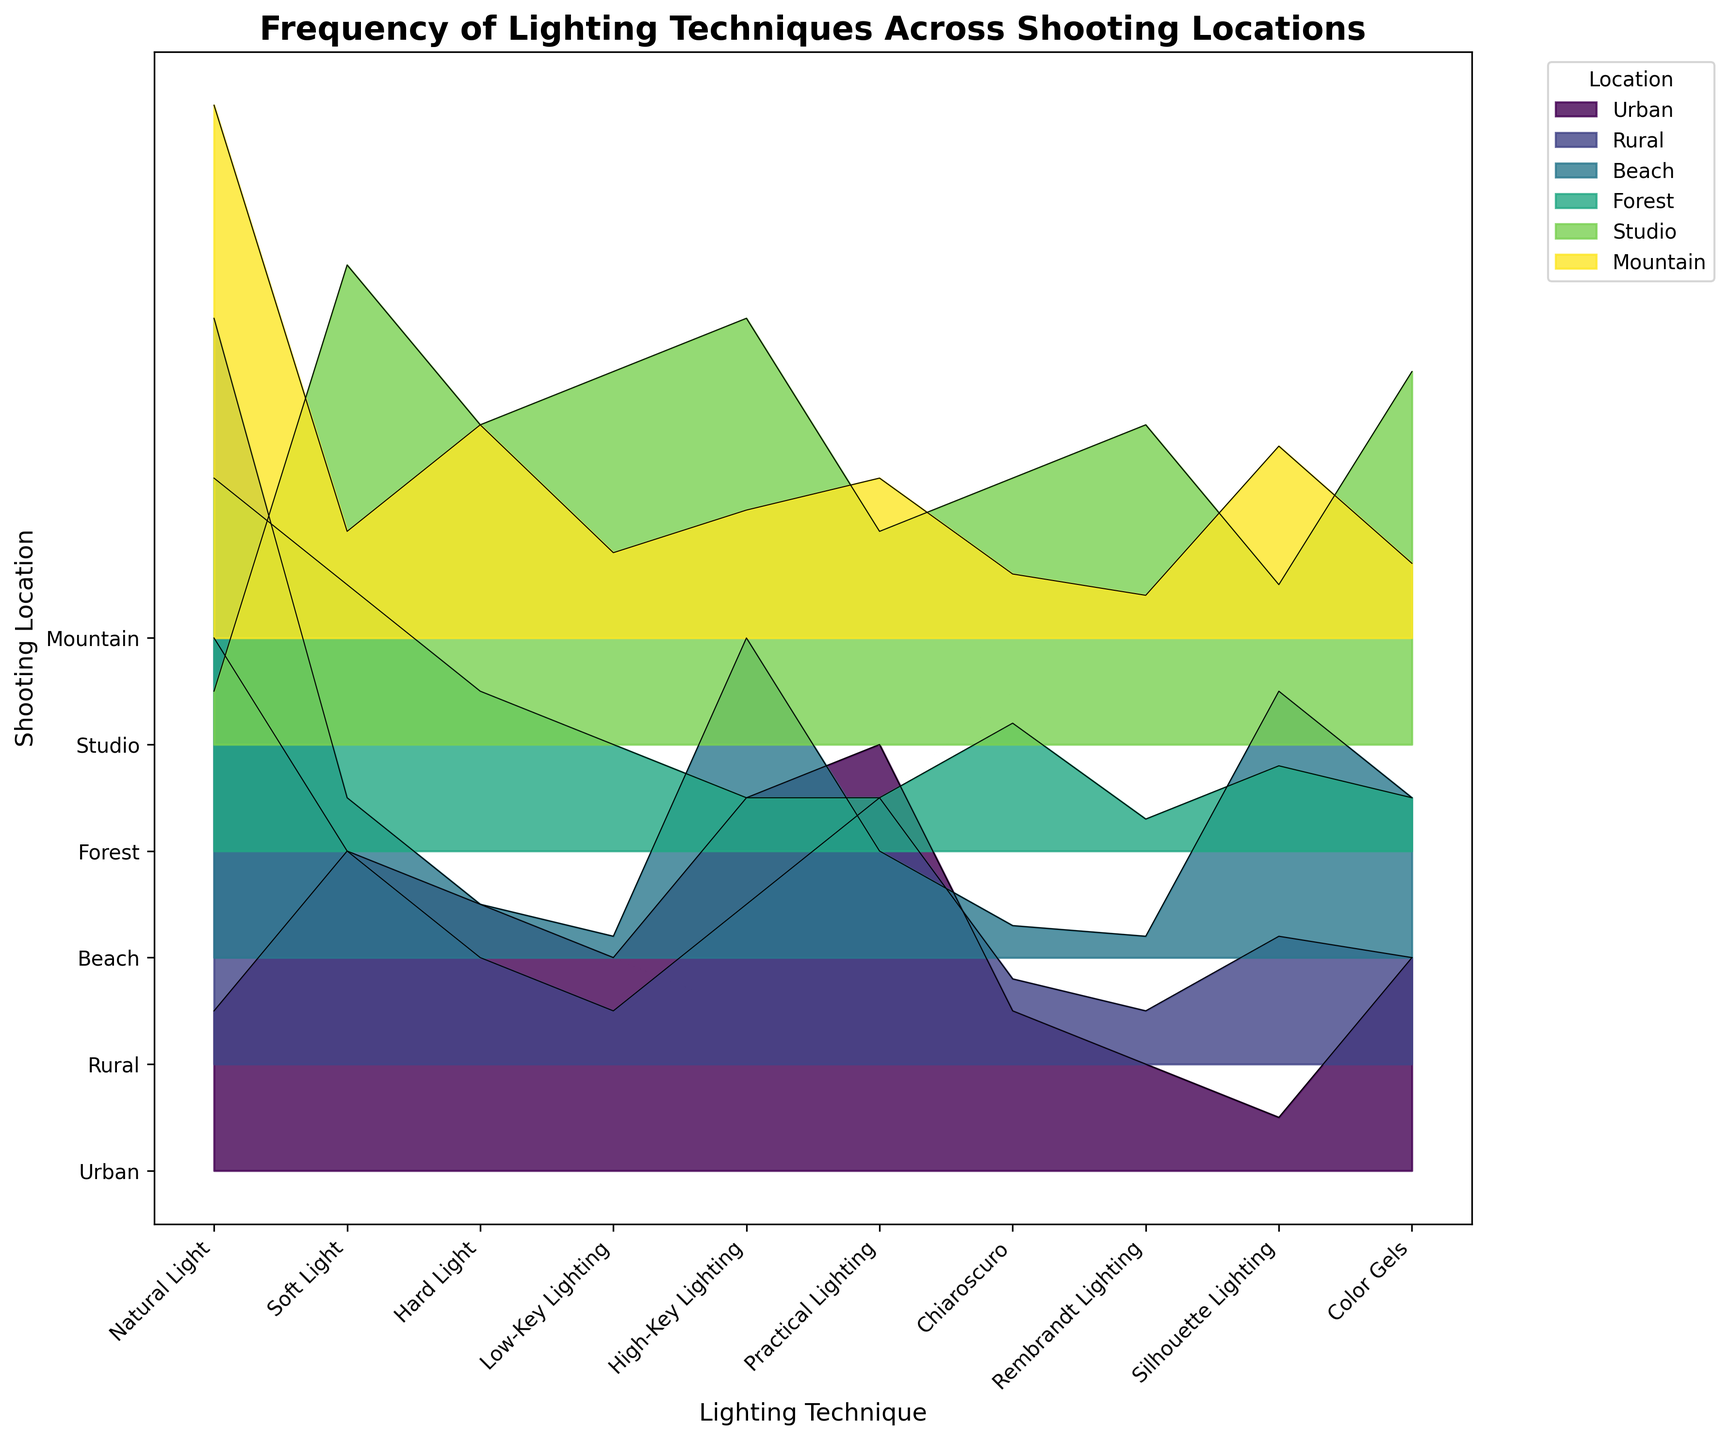What is the title of the figure? The title is prominently displayed at the top of the figure. It reads 'Frequency of Lighting Techniques Across Shooting Locations'.
Answer: Frequency of Lighting Techniques Across Shooting Locations Which lighting technique is most frequently used in Urban locations? By looking at the Urban layer, the technique with the highest line value in the Urban layer is Practical Lighting.
Answer: Practical Lighting Which two lighting techniques have the least frequency in the Studio location? Observe the Studio layer and identify the lighting techniques with the lowest values, which are Natural Light and Rembrandt Lighting.
Answer: Natural Light and Rembrandt Lighting What is the average frequency of Natural Light across all locations? Add all the frequencies of Natural Light across locations: 15 (Urban) + 40 (Rural) + 60 (Beach) + 35 (Forest) + 5 (Studio) + 50 (Mountain) = 205. Then divide by the number of locations (6) to get the average: 205/6 = 34.17.
Answer: 34.17 Which location has the highest frequency of Soft Light? Compare the heights of the Soft Light segments across all locations. The highest segment for Soft Light is in the Studio location.
Answer: Studio How does the frequency of High-Key Lighting in Urban locations compare to its frequency in Beach locations? Check the respective heights of High-Key Lighting segments for Urban and Beach locations. Urban has a frequency of 35, while Beach has a frequency of 30, so Urban is slightly higher.
Answer: Urban is higher Calculate the difference in frequency between Natural Light and Hard Light in Mountain locations. Check the values for Mountain: Natural Light is 50 and Hard Light is 20. The difference is 50 - 20 = 30.
Answer: 30 What is the most varied lighting technique in terms of frequency across all locations? This involves observing which lighting technique has the most variation (range) in heights across different locations. Natural Light varies significantly across locations from 5 to 60.
Answer: Natural Light Identify the location where Low-Key Lighting is used the least and the corresponding frequency. Look at the Low-Key Lighting segments and identify the shortest one, which is in the Beach location with a frequency of 2.
Answer: Beach, 2 Which location shows a higher prominence of Chiaroscuro compared to Silhouette Lighting? For each location, compare the heights of Chiaroscuro and Silhouette Lighting. The Studio location shows a higher prominence of Chiaroscuro (25) compared to Silhouette Lighting (15).
Answer: Studio 